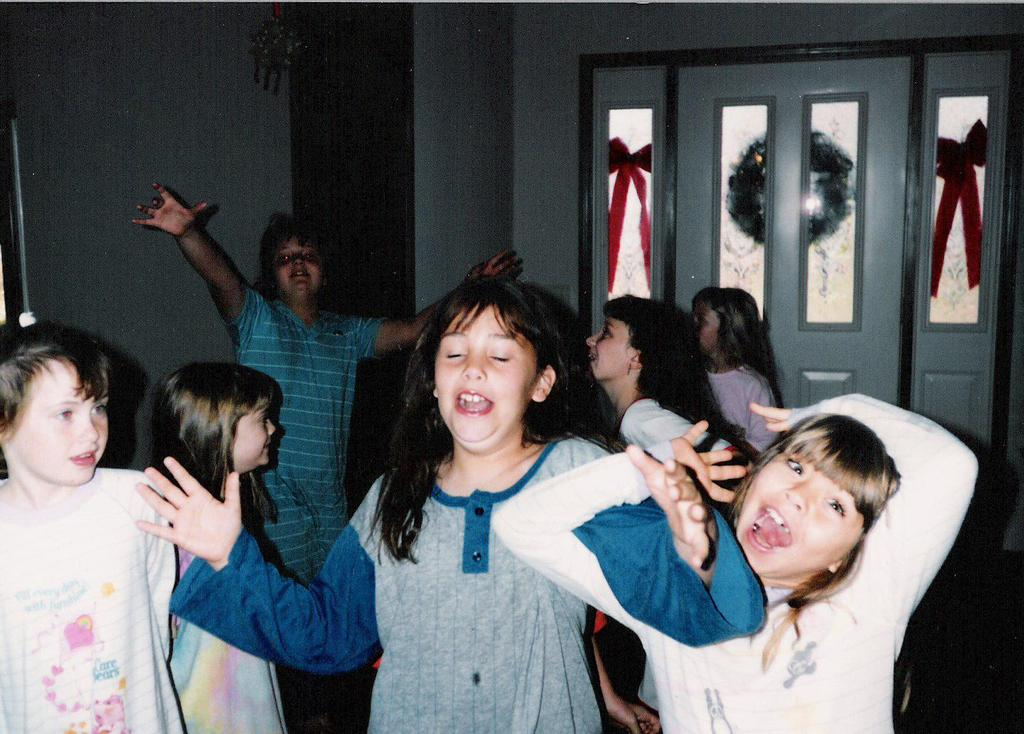What are the main subjects in the image? There are kids playing in the image. Can you describe the setting of the image? The kids are playing in front of a glass door visible in the background of the image. What type of hydrant can be seen in the image? There is no hydrant present in the image. How many pipes are visible in the image? There are no pipes visible in the image. 